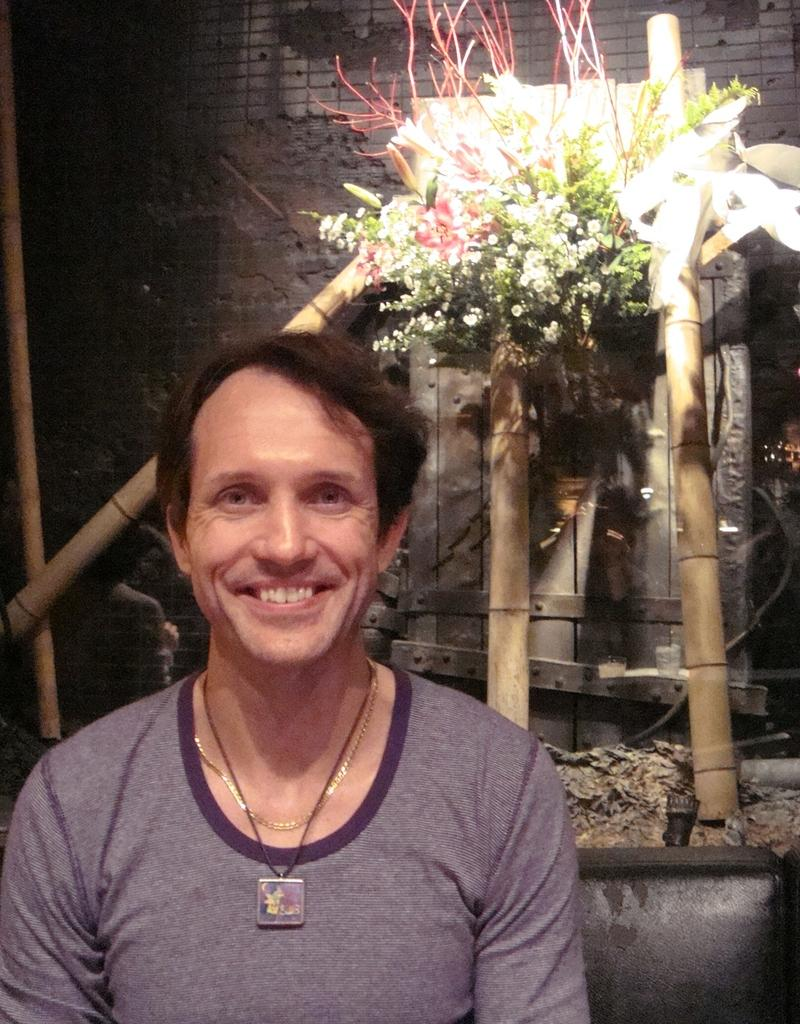What is the main subject in the foreground of the image? There is a person in the foreground of the image. What is the person wearing? The person is wearing a t-shirt. What is the person's facial expression in the image? The person is smiling. What type of vegetation can be seen in the background of the image? There is bamboo visible in the background of the image. What other types of plants can be seen in the background? There are flowers in the background of the image. What type of structure is visible in the background? There is a wall in the background of the image. What other items can be seen in the background? There are other items visible in the background of the image. How does the person change their appearance every minute in the image? The person does not change their appearance every minute in the image; they are wearing a t-shirt and smiling consistently throughout the image. 